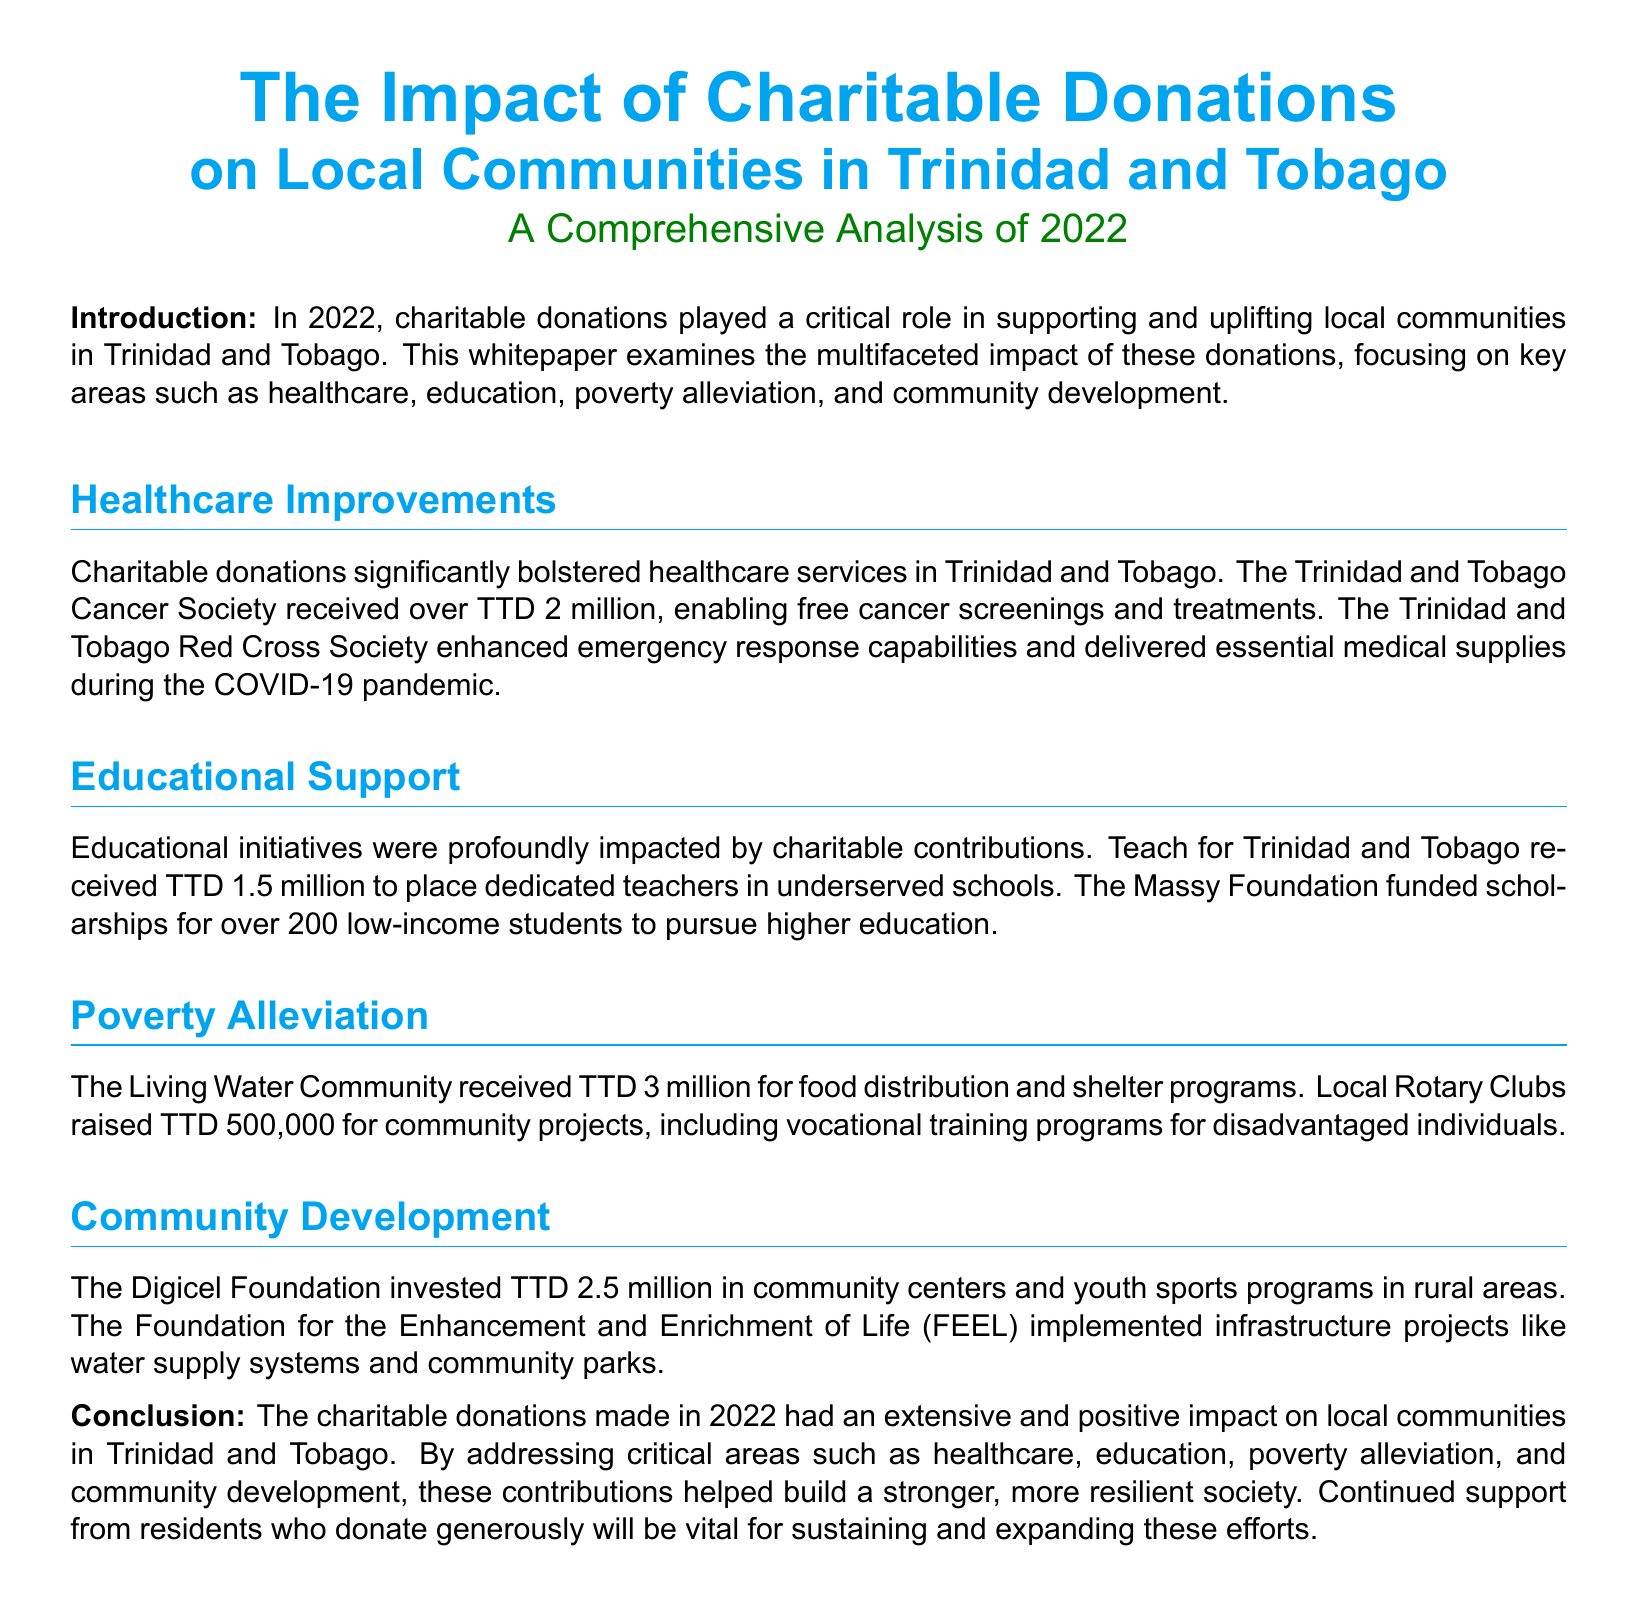what was the total donation received by the Trinidad and Tobago Cancer Society? The document states that the Trinidad and Tobago Cancer Society received over TTD 2 million.
Answer: over TTD 2 million how much funding did Teach for Trinidad and Tobago receive? According to the document, Teach for Trinidad and Tobago received TTD 1.5 million.
Answer: TTD 1.5 million what is the amount donated to the Living Water Community for their programs? The document mentions that the Living Water Community received TTD 3 million for food distribution and shelter programs.
Answer: TTD 3 million which organization funded scholarships for over 200 students? The document notes that the Massy Foundation funded scholarships for over 200 low-income students.
Answer: Massy Foundation what year is analyzed in the whitepaper? The introduction specifies that the analysis focuses on the year 2022.
Answer: 2022 which foundation invested in community centers and youth sports programs? The document indicates that the Digicel Foundation invested in these areas.
Answer: Digicel Foundation how much did local Rotary Clubs raise for community projects? The document states that local Rotary Clubs raised TTD 500,000 for community projects.
Answer: TTD 500,000 what critical areas do charitable donations address according to the conclusion? The conclusion highlights healthcare, education, poverty alleviation, and community development as critical areas.
Answer: healthcare, education, poverty alleviation, and community development what was the primary focus of the whitepaper? The document specifies that the whitepaper examines the impact of charitable donations on local communities.
Answer: the impact of charitable donations on local communities 